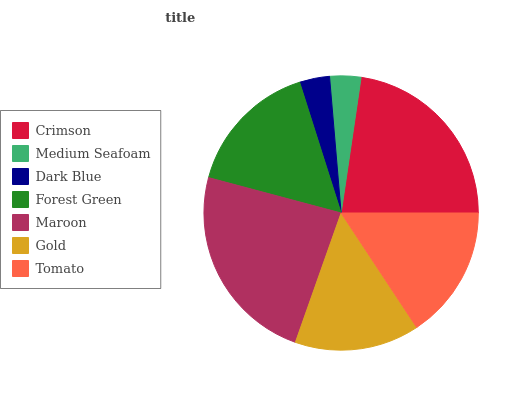Is Dark Blue the minimum?
Answer yes or no. Yes. Is Maroon the maximum?
Answer yes or no. Yes. Is Medium Seafoam the minimum?
Answer yes or no. No. Is Medium Seafoam the maximum?
Answer yes or no. No. Is Crimson greater than Medium Seafoam?
Answer yes or no. Yes. Is Medium Seafoam less than Crimson?
Answer yes or no. Yes. Is Medium Seafoam greater than Crimson?
Answer yes or no. No. Is Crimson less than Medium Seafoam?
Answer yes or no. No. Is Tomato the high median?
Answer yes or no. Yes. Is Tomato the low median?
Answer yes or no. Yes. Is Medium Seafoam the high median?
Answer yes or no. No. Is Gold the low median?
Answer yes or no. No. 